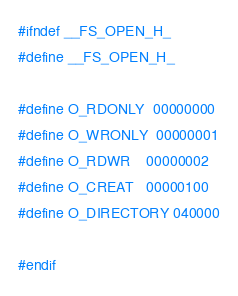<code> <loc_0><loc_0><loc_500><loc_500><_C_>#ifndef __FS_OPEN_H_
#define __FS_OPEN_H_

#define O_RDONLY  00000000
#define O_WRONLY  00000001
#define O_RDWR    00000002
#define O_CREAT   00000100
#define O_DIRECTORY 040000

#endif</code> 